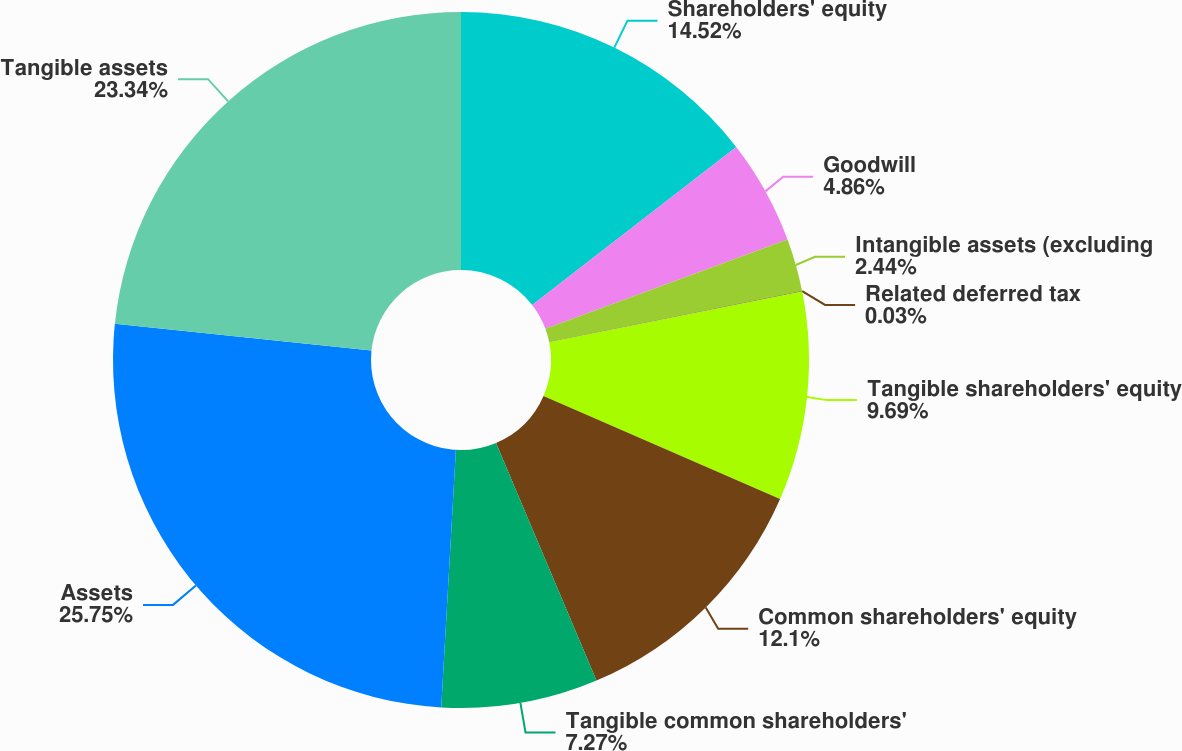Convert chart to OTSL. <chart><loc_0><loc_0><loc_500><loc_500><pie_chart><fcel>Shareholders' equity<fcel>Goodwill<fcel>Intangible assets (excluding<fcel>Related deferred tax<fcel>Tangible shareholders' equity<fcel>Common shareholders' equity<fcel>Tangible common shareholders'<fcel>Assets<fcel>Tangible assets<nl><fcel>14.52%<fcel>4.86%<fcel>2.44%<fcel>0.03%<fcel>9.69%<fcel>12.1%<fcel>7.27%<fcel>25.76%<fcel>23.34%<nl></chart> 